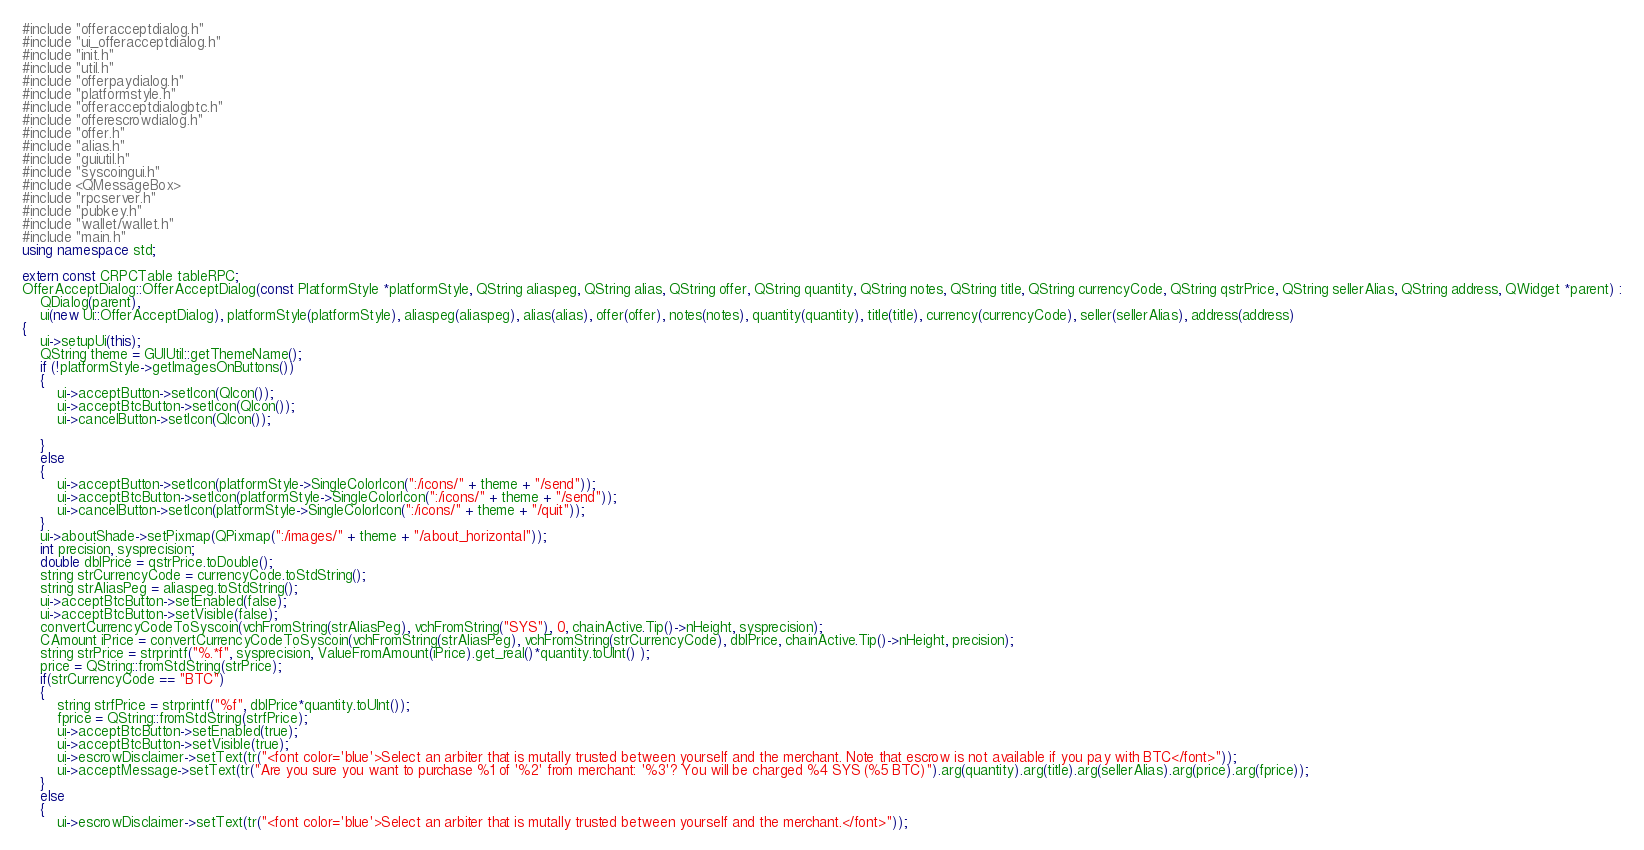Convert code to text. <code><loc_0><loc_0><loc_500><loc_500><_C++_>#include "offeracceptdialog.h"
#include "ui_offeracceptdialog.h"
#include "init.h"
#include "util.h"
#include "offerpaydialog.h"
#include "platformstyle.h"
#include "offeracceptdialogbtc.h"
#include "offerescrowdialog.h"
#include "offer.h"
#include "alias.h"
#include "guiutil.h"
#include "syscoingui.h"
#include <QMessageBox>
#include "rpcserver.h"
#include "pubkey.h"
#include "wallet/wallet.h"
#include "main.h"
using namespace std;

extern const CRPCTable tableRPC;
OfferAcceptDialog::OfferAcceptDialog(const PlatformStyle *platformStyle, QString aliaspeg, QString alias, QString offer, QString quantity, QString notes, QString title, QString currencyCode, QString qstrPrice, QString sellerAlias, QString address, QWidget *parent) :
    QDialog(parent),
    ui(new Ui::OfferAcceptDialog), platformStyle(platformStyle), aliaspeg(aliaspeg), alias(alias), offer(offer), notes(notes), quantity(quantity), title(title), currency(currencyCode), seller(sellerAlias), address(address)
{
    ui->setupUi(this);
	QString theme = GUIUtil::getThemeName();  
	if (!platformStyle->getImagesOnButtons())
	{
		ui->acceptButton->setIcon(QIcon());
		ui->acceptBtcButton->setIcon(QIcon());
		ui->cancelButton->setIcon(QIcon());

	}
	else
	{
		ui->acceptButton->setIcon(platformStyle->SingleColorIcon(":/icons/" + theme + "/send"));
		ui->acceptBtcButton->setIcon(platformStyle->SingleColorIcon(":/icons/" + theme + "/send"));
		ui->cancelButton->setIcon(platformStyle->SingleColorIcon(":/icons/" + theme + "/quit"));
	}
	ui->aboutShade->setPixmap(QPixmap(":/images/" + theme + "/about_horizontal"));
	int precision, sysprecision;
	double dblPrice = qstrPrice.toDouble();
	string strCurrencyCode = currencyCode.toStdString();
	string strAliasPeg = aliaspeg.toStdString();
	ui->acceptBtcButton->setEnabled(false);
	ui->acceptBtcButton->setVisible(false);
	convertCurrencyCodeToSyscoin(vchFromString(strAliasPeg), vchFromString("SYS"), 0, chainActive.Tip()->nHeight, sysprecision);
	CAmount iPrice = convertCurrencyCodeToSyscoin(vchFromString(strAliasPeg), vchFromString(strCurrencyCode), dblPrice, chainActive.Tip()->nHeight, precision);
	string strPrice = strprintf("%.*f", sysprecision, ValueFromAmount(iPrice).get_real()*quantity.toUInt() );
	price = QString::fromStdString(strPrice);
	if(strCurrencyCode == "BTC")
	{
		string strfPrice = strprintf("%f", dblPrice*quantity.toUInt());
		fprice = QString::fromStdString(strfPrice);
		ui->acceptBtcButton->setEnabled(true);
		ui->acceptBtcButton->setVisible(true);
		ui->escrowDisclaimer->setText(tr("<font color='blue'>Select an arbiter that is mutally trusted between yourself and the merchant. Note that escrow is not available if you pay with BTC</font>"));
		ui->acceptMessage->setText(tr("Are you sure you want to purchase %1 of '%2' from merchant: '%3'? You will be charged %4 SYS (%5 BTC)").arg(quantity).arg(title).arg(sellerAlias).arg(price).arg(fprice));
	}
	else
	{
		ui->escrowDisclaimer->setText(tr("<font color='blue'>Select an arbiter that is mutally trusted between yourself and the merchant.</font>"));</code> 